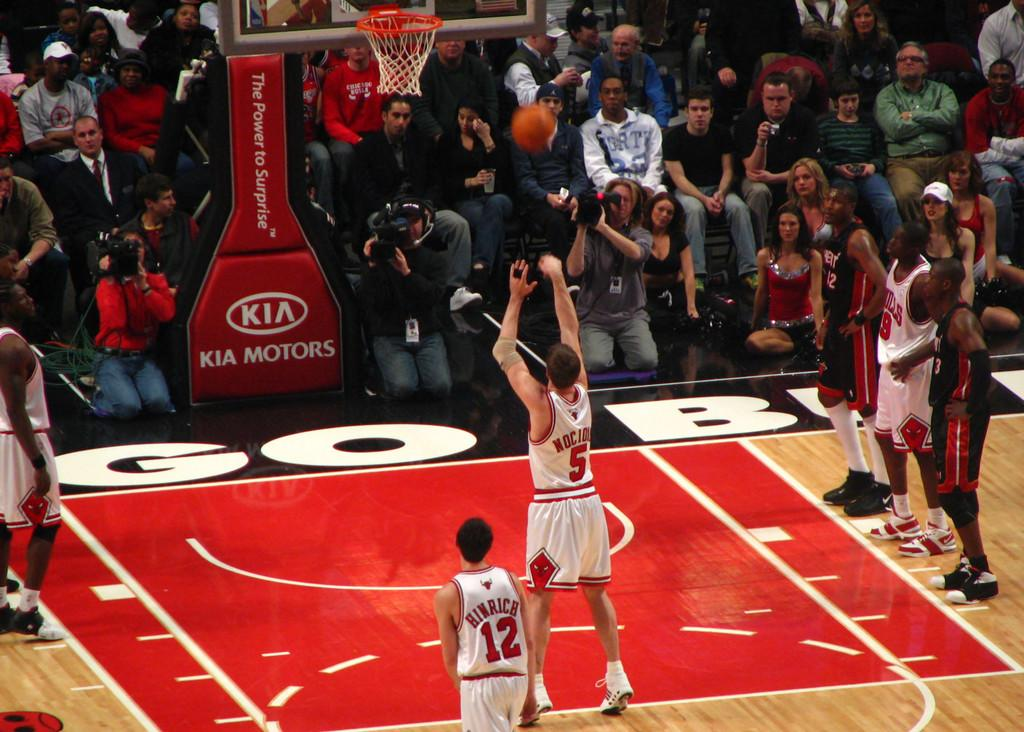<image>
Provide a brief description of the given image. A Chicago Bulls player doing a layup in front of a bunch of other people 